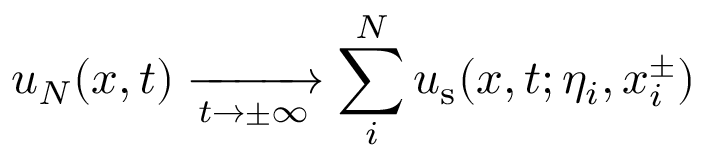<formula> <loc_0><loc_0><loc_500><loc_500>u _ { N } ( x , t ) \xrightarrow [ t \to \pm \infty \sum _ { i } ^ { N } u _ { s } ( x , t ; \eta _ { i } , x _ { i } ^ { \pm } )</formula> 